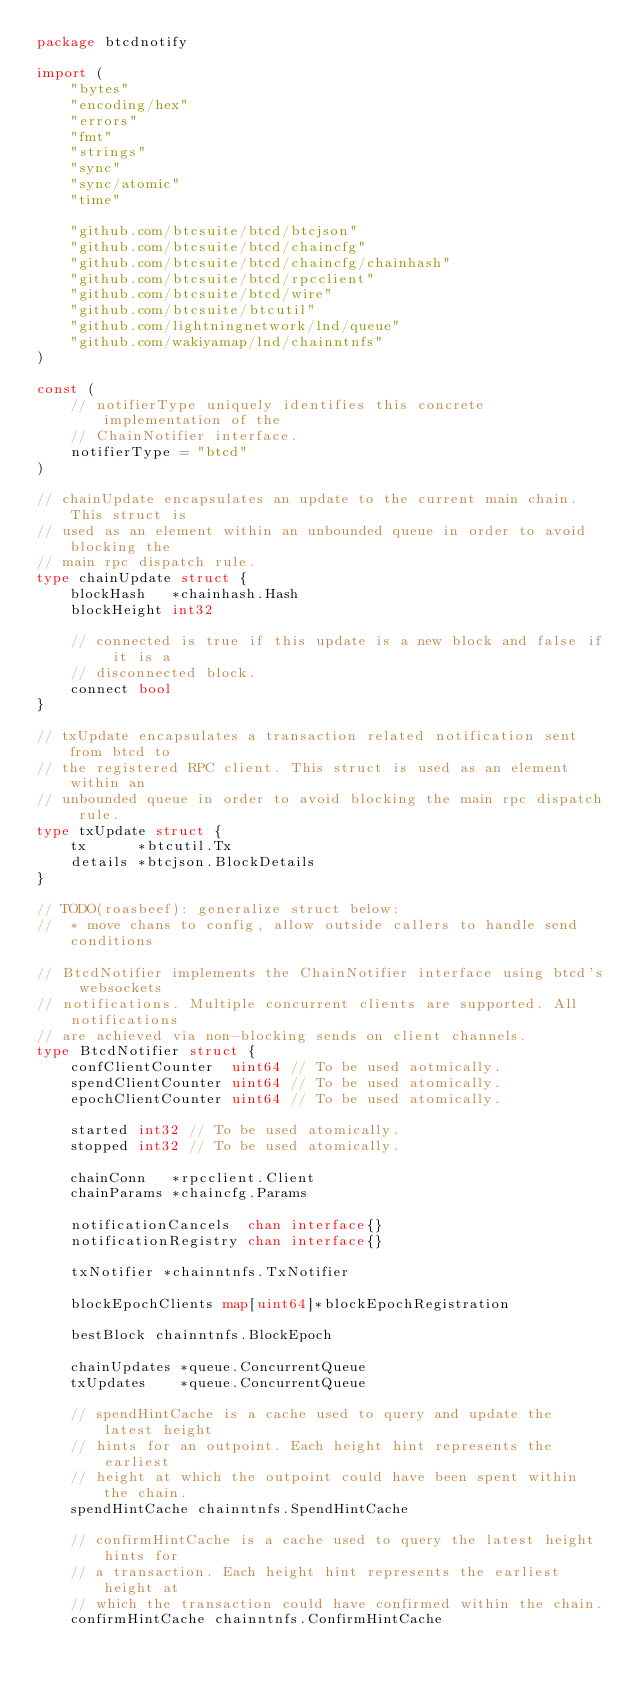Convert code to text. <code><loc_0><loc_0><loc_500><loc_500><_Go_>package btcdnotify

import (
	"bytes"
	"encoding/hex"
	"errors"
	"fmt"
	"strings"
	"sync"
	"sync/atomic"
	"time"

	"github.com/btcsuite/btcd/btcjson"
	"github.com/btcsuite/btcd/chaincfg"
	"github.com/btcsuite/btcd/chaincfg/chainhash"
	"github.com/btcsuite/btcd/rpcclient"
	"github.com/btcsuite/btcd/wire"
	"github.com/btcsuite/btcutil"
	"github.com/lightningnetwork/lnd/queue"
	"github.com/wakiyamap/lnd/chainntnfs"
)

const (
	// notifierType uniquely identifies this concrete implementation of the
	// ChainNotifier interface.
	notifierType = "btcd"
)

// chainUpdate encapsulates an update to the current main chain. This struct is
// used as an element within an unbounded queue in order to avoid blocking the
// main rpc dispatch rule.
type chainUpdate struct {
	blockHash   *chainhash.Hash
	blockHeight int32

	// connected is true if this update is a new block and false if it is a
	// disconnected block.
	connect bool
}

// txUpdate encapsulates a transaction related notification sent from btcd to
// the registered RPC client. This struct is used as an element within an
// unbounded queue in order to avoid blocking the main rpc dispatch rule.
type txUpdate struct {
	tx      *btcutil.Tx
	details *btcjson.BlockDetails
}

// TODO(roasbeef): generalize struct below:
//  * move chans to config, allow outside callers to handle send conditions

// BtcdNotifier implements the ChainNotifier interface using btcd's websockets
// notifications. Multiple concurrent clients are supported. All notifications
// are achieved via non-blocking sends on client channels.
type BtcdNotifier struct {
	confClientCounter  uint64 // To be used aotmically.
	spendClientCounter uint64 // To be used atomically.
	epochClientCounter uint64 // To be used atomically.

	started int32 // To be used atomically.
	stopped int32 // To be used atomically.

	chainConn   *rpcclient.Client
	chainParams *chaincfg.Params

	notificationCancels  chan interface{}
	notificationRegistry chan interface{}

	txNotifier *chainntnfs.TxNotifier

	blockEpochClients map[uint64]*blockEpochRegistration

	bestBlock chainntnfs.BlockEpoch

	chainUpdates *queue.ConcurrentQueue
	txUpdates    *queue.ConcurrentQueue

	// spendHintCache is a cache used to query and update the latest height
	// hints for an outpoint. Each height hint represents the earliest
	// height at which the outpoint could have been spent within the chain.
	spendHintCache chainntnfs.SpendHintCache

	// confirmHintCache is a cache used to query the latest height hints for
	// a transaction. Each height hint represents the earliest height at
	// which the transaction could have confirmed within the chain.
	confirmHintCache chainntnfs.ConfirmHintCache
</code> 